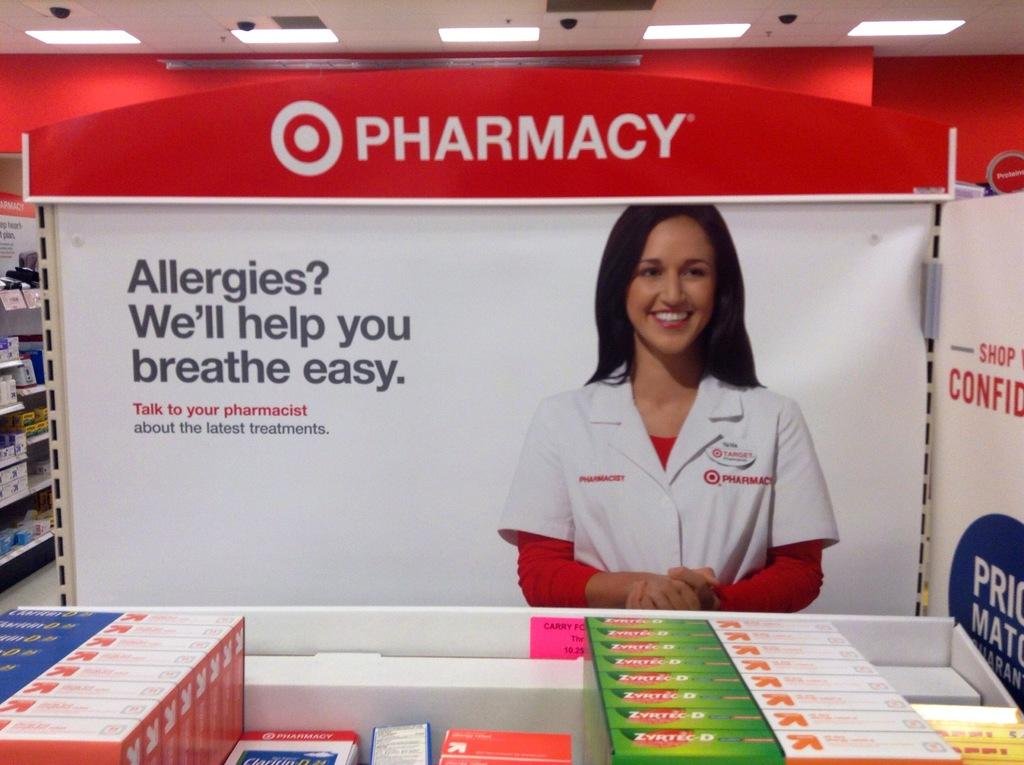<image>
Summarize the visual content of the image. Pharmacy that sells medicine for allergies that will help you breath easy 